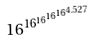Convert formula to latex. <formula><loc_0><loc_0><loc_500><loc_500>1 6 ^ { 1 6 ^ { 1 6 ^ { 1 6 ^ { 1 6 ^ { 4 . 5 2 7 } } } } }</formula> 